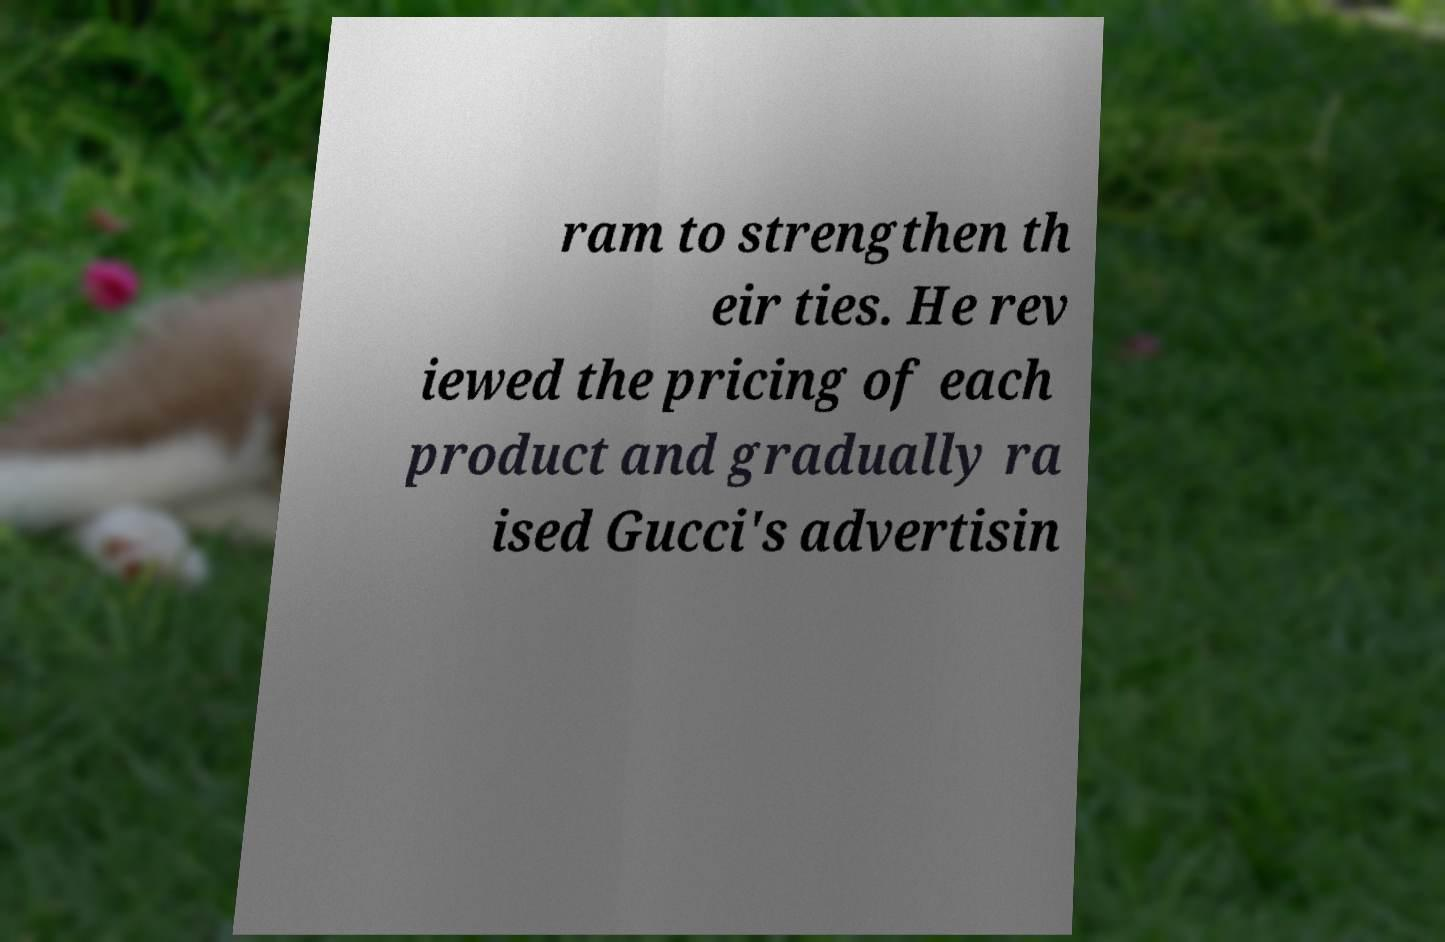For documentation purposes, I need the text within this image transcribed. Could you provide that? ram to strengthen th eir ties. He rev iewed the pricing of each product and gradually ra ised Gucci's advertisin 